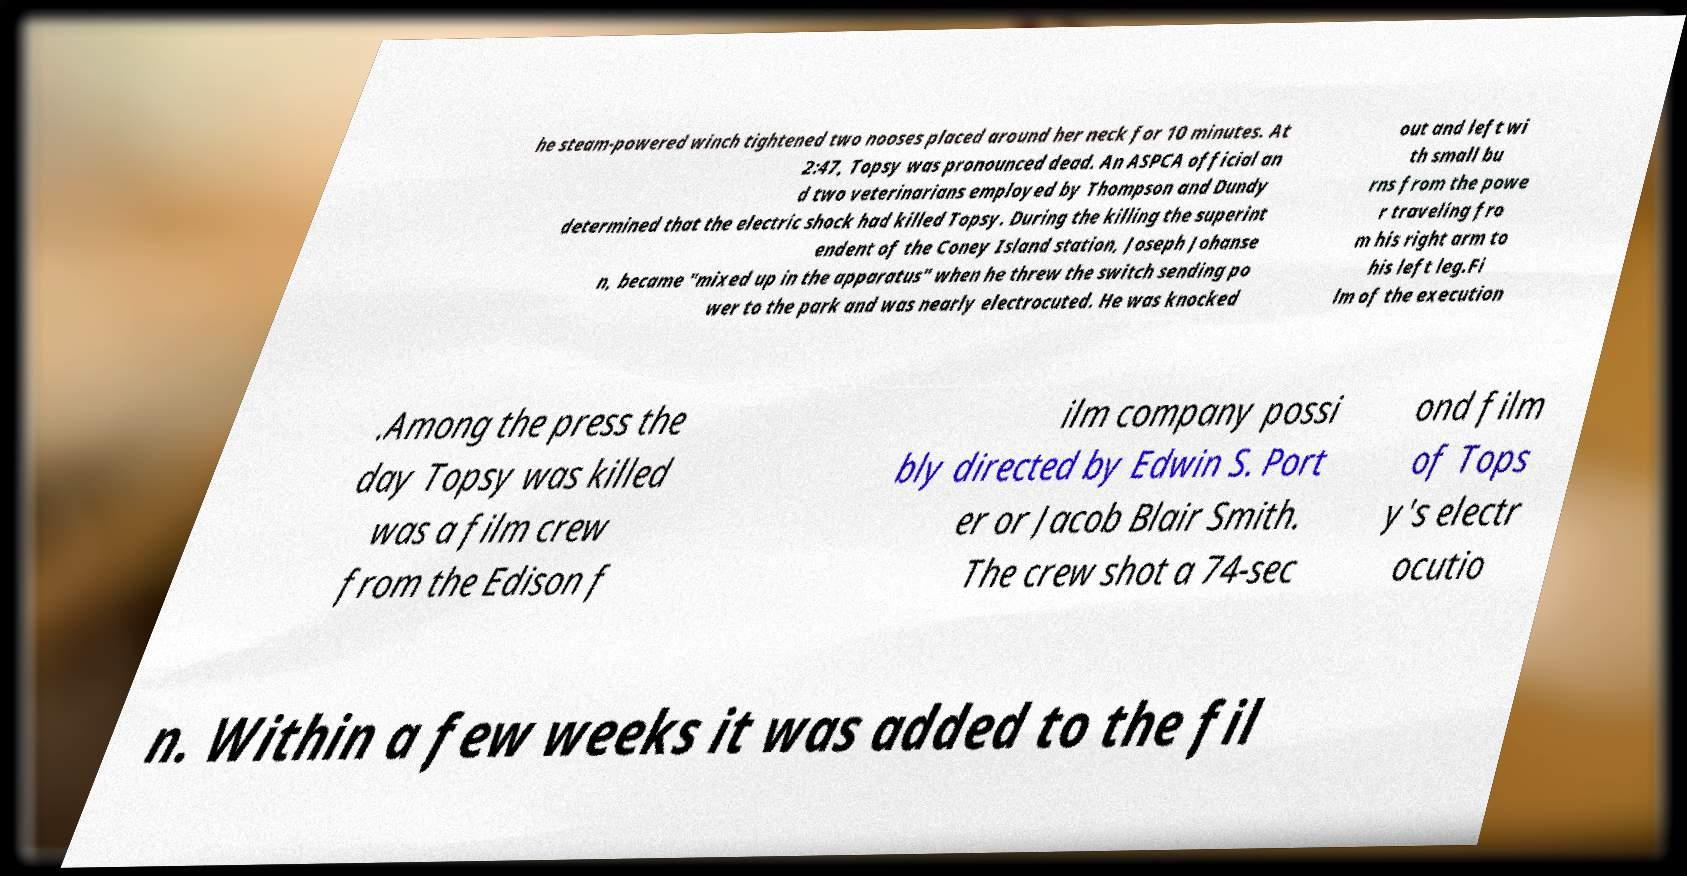I need the written content from this picture converted into text. Can you do that? he steam-powered winch tightened two nooses placed around her neck for 10 minutes. At 2:47, Topsy was pronounced dead. An ASPCA official an d two veterinarians employed by Thompson and Dundy determined that the electric shock had killed Topsy. During the killing the superint endent of the Coney Island station, Joseph Johanse n, became "mixed up in the apparatus" when he threw the switch sending po wer to the park and was nearly electrocuted. He was knocked out and left wi th small bu rns from the powe r traveling fro m his right arm to his left leg.Fi lm of the execution .Among the press the day Topsy was killed was a film crew from the Edison f ilm company possi bly directed by Edwin S. Port er or Jacob Blair Smith. The crew shot a 74-sec ond film of Tops y's electr ocutio n. Within a few weeks it was added to the fil 